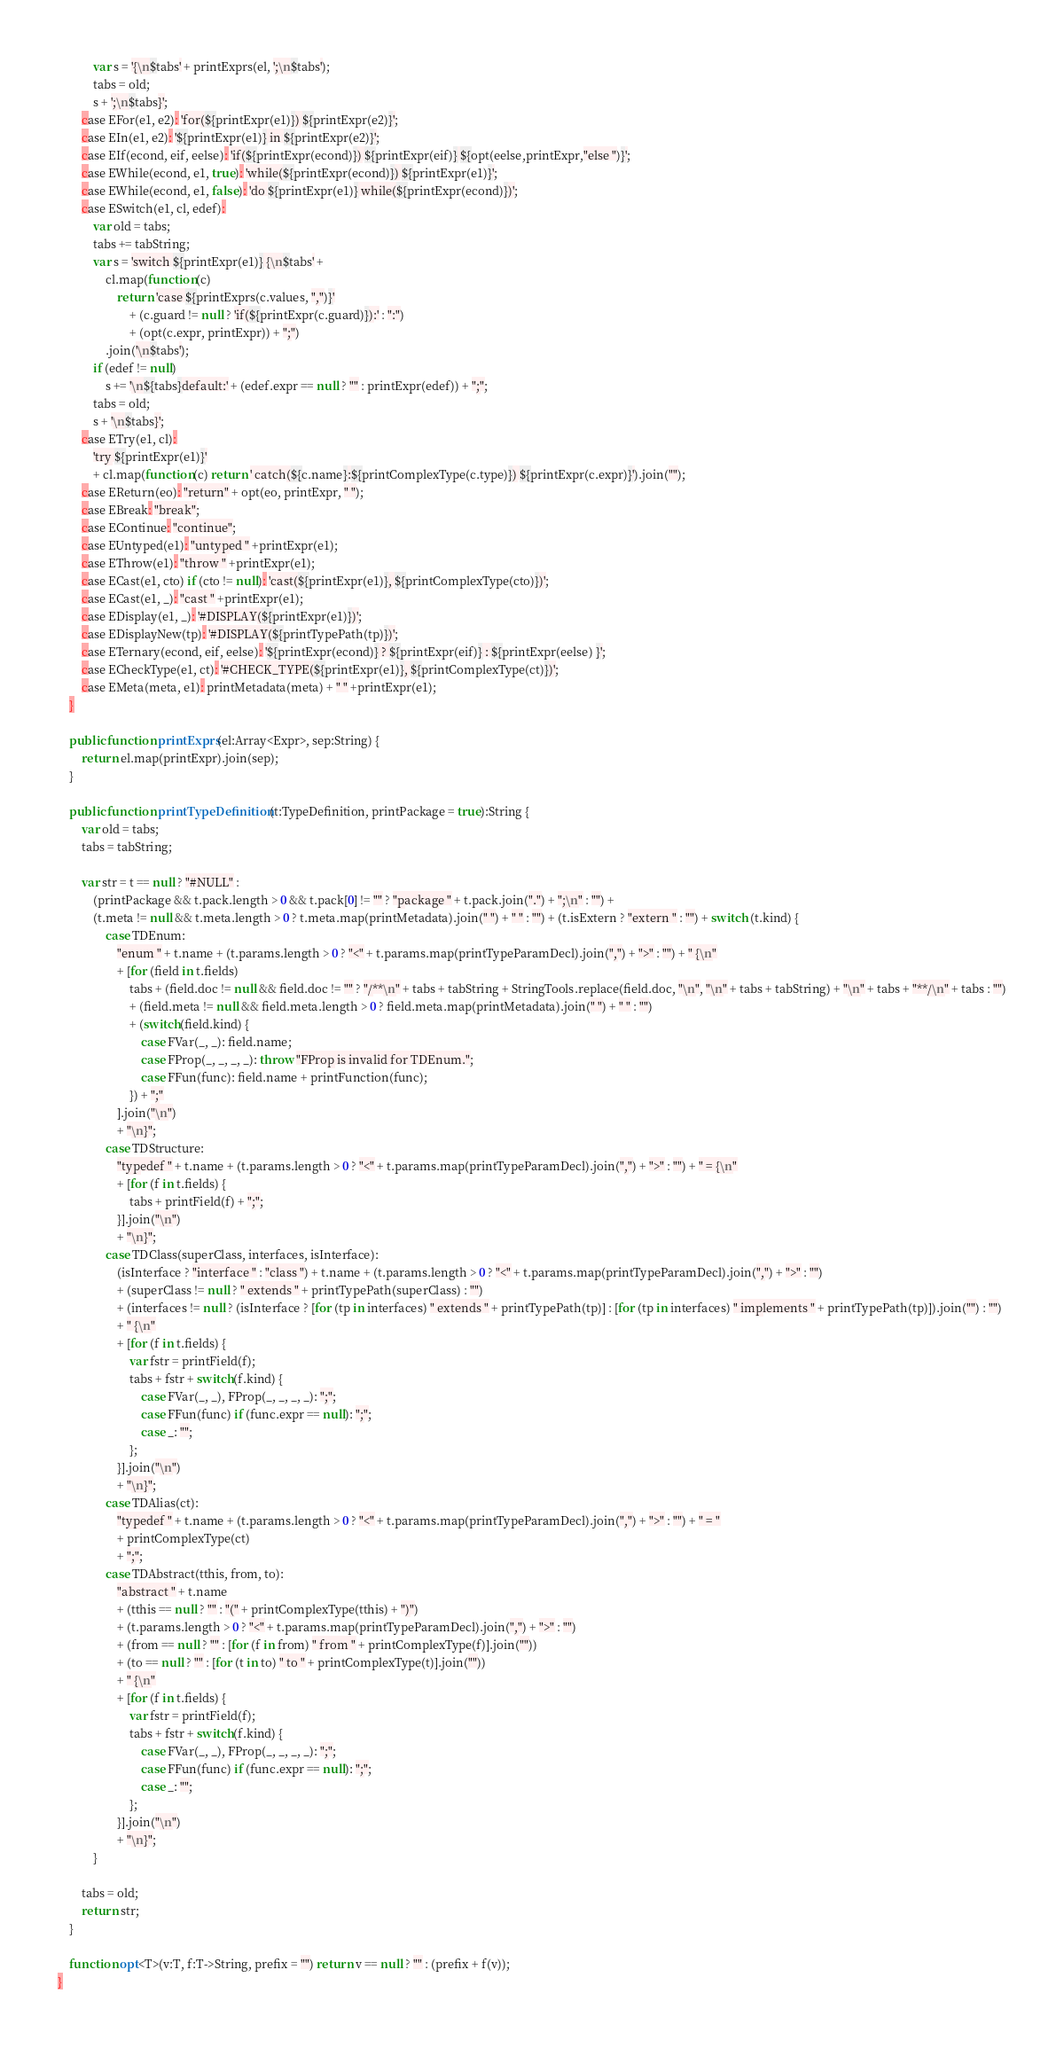<code> <loc_0><loc_0><loc_500><loc_500><_Haxe_>			var s = '{\n$tabs' + printExprs(el, ';\n$tabs');
			tabs = old;
			s + ';\n$tabs}';
		case EFor(e1, e2): 'for(${printExpr(e1)}) ${printExpr(e2)}';
		case EIn(e1, e2): '${printExpr(e1)} in ${printExpr(e2)}';
		case EIf(econd, eif, eelse): 'if(${printExpr(econd)}) ${printExpr(eif)} ${opt(eelse,printExpr,"else ")}';
		case EWhile(econd, e1, true): 'while(${printExpr(econd)}) ${printExpr(e1)}';
		case EWhile(econd, e1, false): 'do ${printExpr(e1)} while(${printExpr(econd)})';
		case ESwitch(e1, cl, edef):
			var old = tabs;
			tabs += tabString;
			var s = 'switch ${printExpr(e1)} {\n$tabs' +
				cl.map(function(c)
					return 'case ${printExprs(c.values, ",")}'
						+ (c.guard != null ? 'if(${printExpr(c.guard)}):' : ":")
						+ (opt(c.expr, printExpr)) + ";")
				.join('\n$tabs');
			if (edef != null)
				s += '\n${tabs}default:' + (edef.expr == null ? "" : printExpr(edef)) + ";";
			tabs = old;
			s + '\n$tabs}';
		case ETry(e1, cl):
			'try ${printExpr(e1)}'
			+ cl.map(function(c) return ' catch(${c.name}:${printComplexType(c.type)}) ${printExpr(c.expr)}').join("");
		case EReturn(eo): "return" + opt(eo, printExpr, " ");
		case EBreak: "break";
		case EContinue: "continue";
		case EUntyped(e1): "untyped " +printExpr(e1);
		case EThrow(e1): "throw " +printExpr(e1);
		case ECast(e1, cto) if (cto != null): 'cast(${printExpr(e1)}, ${printComplexType(cto)})';
		case ECast(e1, _): "cast " +printExpr(e1);
		case EDisplay(e1, _): '#DISPLAY(${printExpr(e1)})';
		case EDisplayNew(tp): '#DISPLAY(${printTypePath(tp)})';
		case ETernary(econd, eif, eelse): '${printExpr(econd)} ? ${printExpr(eif)} : ${printExpr(eelse) }';
		case ECheckType(e1, ct): '#CHECK_TYPE(${printExpr(e1)}, ${printComplexType(ct)})';
		case EMeta(meta, e1): printMetadata(meta) + " " +printExpr(e1);
	}

	public function printExprs(el:Array<Expr>, sep:String) {
		return el.map(printExpr).join(sep);
	}
	
	public function printTypeDefinition(t:TypeDefinition, printPackage = true):String {
		var old = tabs;
		tabs = tabString;
		
		var str = t == null ? "#NULL" :
			(printPackage && t.pack.length > 0 && t.pack[0] != "" ? "package " + t.pack.join(".") + ";\n" : "") +
			(t.meta != null && t.meta.length > 0 ? t.meta.map(printMetadata).join(" ") + " " : "") + (t.isExtern ? "extern " : "") + switch (t.kind) {
				case TDEnum:
					"enum " + t.name + (t.params.length > 0 ? "<" + t.params.map(printTypeParamDecl).join(",") + ">" : "") + " {\n"
					+ [for (field in t.fields)
						tabs + (field.doc != null && field.doc != "" ? "/**\n" + tabs + tabString + StringTools.replace(field.doc, "\n", "\n" + tabs + tabString) + "\n" + tabs + "**/\n" + tabs : "")
						+ (field.meta != null && field.meta.length > 0 ? field.meta.map(printMetadata).join(" ") + " " : "")
						+ (switch(field.kind) {
							case FVar(_, _): field.name;
							case FProp(_, _, _, _): throw "FProp is invalid for TDEnum.";
							case FFun(func): field.name + printFunction(func);
						}) + ";"
					].join("\n")
					+ "\n}";
				case TDStructure:
					"typedef " + t.name + (t.params.length > 0 ? "<" + t.params.map(printTypeParamDecl).join(",") + ">" : "") + " = {\n"
					+ [for (f in t.fields) {
						tabs + printField(f) + ";";
					}].join("\n")
					+ "\n}";
				case TDClass(superClass, interfaces, isInterface):
					(isInterface ? "interface " : "class ") + t.name + (t.params.length > 0 ? "<" + t.params.map(printTypeParamDecl).join(",") + ">" : "")
					+ (superClass != null ? " extends " + printTypePath(superClass) : "")
					+ (interfaces != null ? (isInterface ? [for (tp in interfaces) " extends " + printTypePath(tp)] : [for (tp in interfaces) " implements " + printTypePath(tp)]).join("") : "")
					+ " {\n"
					+ [for (f in t.fields) {
						var fstr = printField(f);
						tabs + fstr + switch(f.kind) {
							case FVar(_, _), FProp(_, _, _, _): ";";
							case FFun(func) if (func.expr == null): ";";
							case _: "";
						};
					}].join("\n")
					+ "\n}";
				case TDAlias(ct):
					"typedef " + t.name + (t.params.length > 0 ? "<" + t.params.map(printTypeParamDecl).join(",") + ">" : "") + " = "
					+ printComplexType(ct)
					+ ";";
				case TDAbstract(tthis, from, to):
					"abstract " + t.name
					+ (tthis == null ? "" : "(" + printComplexType(tthis) + ")")
					+ (t.params.length > 0 ? "<" + t.params.map(printTypeParamDecl).join(",") + ">" : "")
					+ (from == null ? "" : [for (f in from) " from " + printComplexType(f)].join(""))
					+ (to == null ? "" : [for (t in to) " to " + printComplexType(t)].join(""))
					+ " {\n"
					+ [for (f in t.fields) {
						var fstr = printField(f);
						tabs + fstr + switch(f.kind) {
							case FVar(_, _), FProp(_, _, _, _): ";";
							case FFun(func) if (func.expr == null): ";";
							case _: "";
						};
					}].join("\n")
					+ "\n}";
			}
		
		tabs = old;
		return str;
	}

	function opt<T>(v:T, f:T->String, prefix = "") return v == null ? "" : (prefix + f(v));
}</code> 